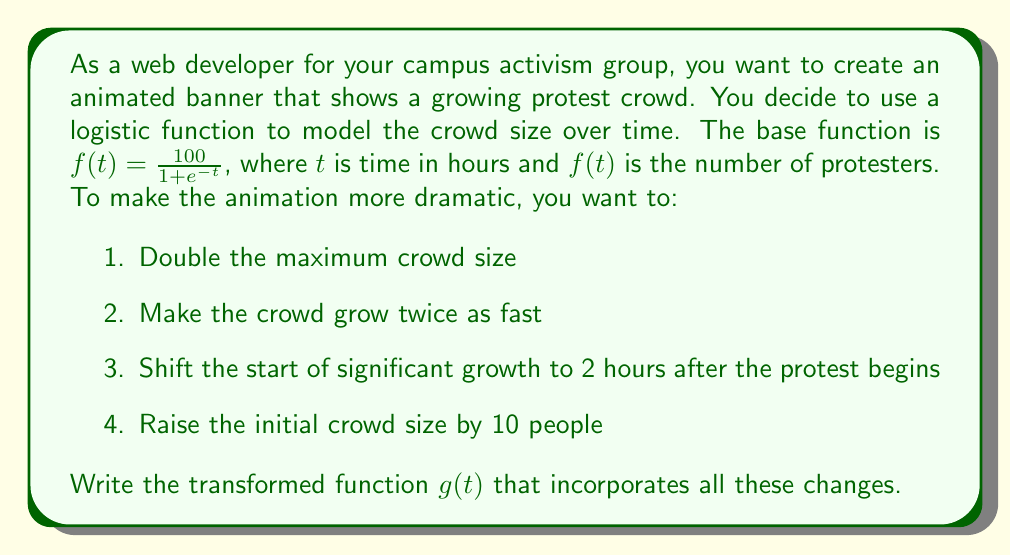Teach me how to tackle this problem. Let's apply the transformations step by step:

1. To double the maximum crowd size, we multiply the entire function by 2:
   $g_1(t) = 2 \cdot \frac{100}{1 + e^{-t}} = \frac{200}{1 + e^{-t}}$

2. To make the crowd grow twice as fast, we multiply $t$ by 2 inside the function:
   $g_2(t) = \frac{200}{1 + e^{-2t}}$

3. To shift the start of significant growth by 2 hours, we subtract 2 from $t$:
   $g_3(t) = \frac{200}{1 + e^{-2(t-2)}}$

4. To raise the initial crowd size by 10 people, we add 10 to the entire function:
   $g(t) = \frac{200}{1 + e^{-2(t-2)}} + 10$

This final form $g(t)$ incorporates all the required transformations.
Answer: $g(t) = \frac{200}{1 + e^{-2(t-2)}} + 10$ 